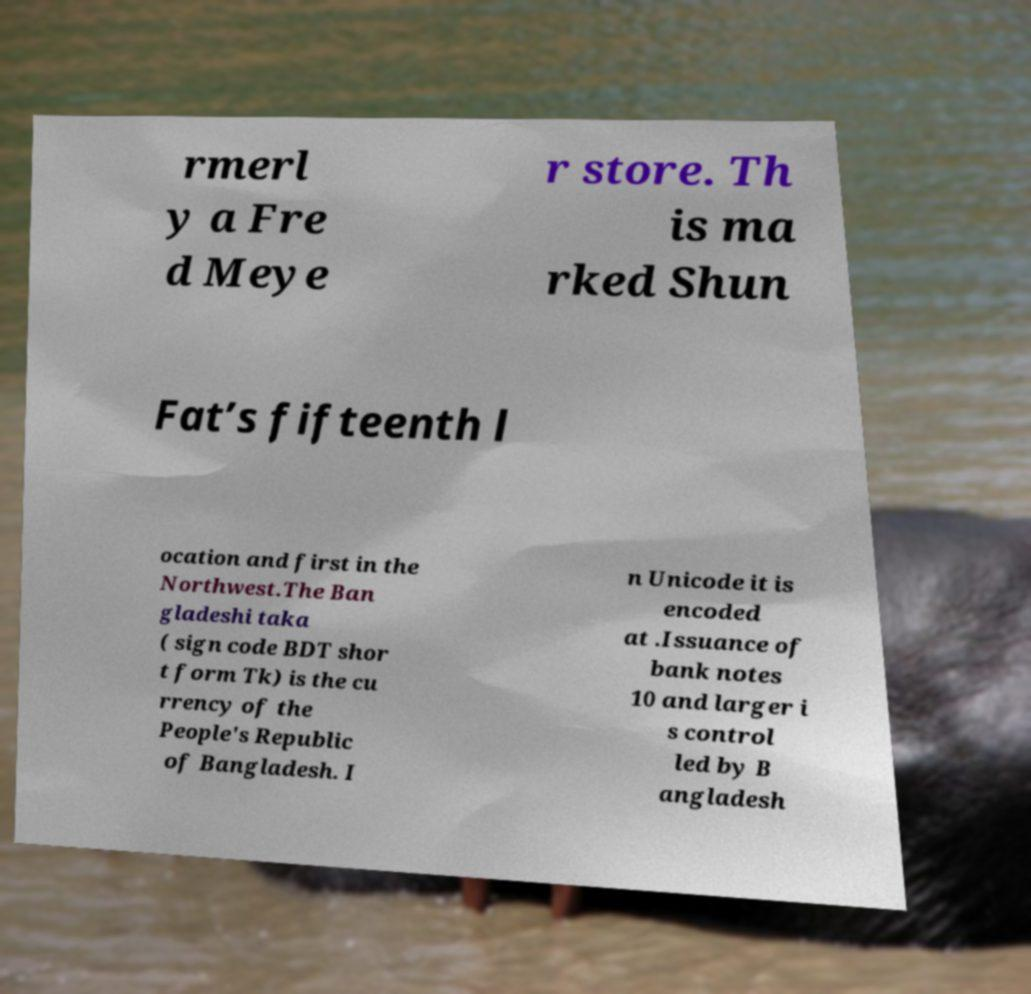Can you read and provide the text displayed in the image?This photo seems to have some interesting text. Can you extract and type it out for me? rmerl y a Fre d Meye r store. Th is ma rked Shun Fat’s fifteenth l ocation and first in the Northwest.The Ban gladeshi taka ( sign code BDT shor t form Tk) is the cu rrency of the People's Republic of Bangladesh. I n Unicode it is encoded at .Issuance of bank notes 10 and larger i s control led by B angladesh 